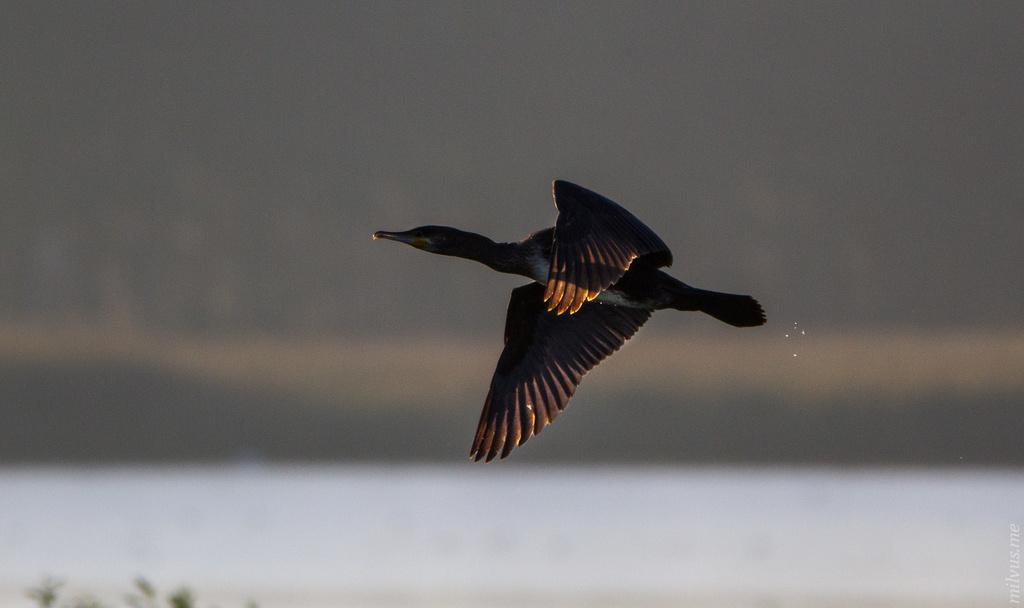What color is the bird in the image? The bird in the image is black-colored. What is the bird doing in the image? The bird is flying in the air. How many surprises can be seen in the image? There are no surprises present in the image; it features a black-colored bird flying in the air. What discovery was made while observing the image? There is no specific discovery mentioned in the image; it simply shows a black-colored bird flying in the air. 